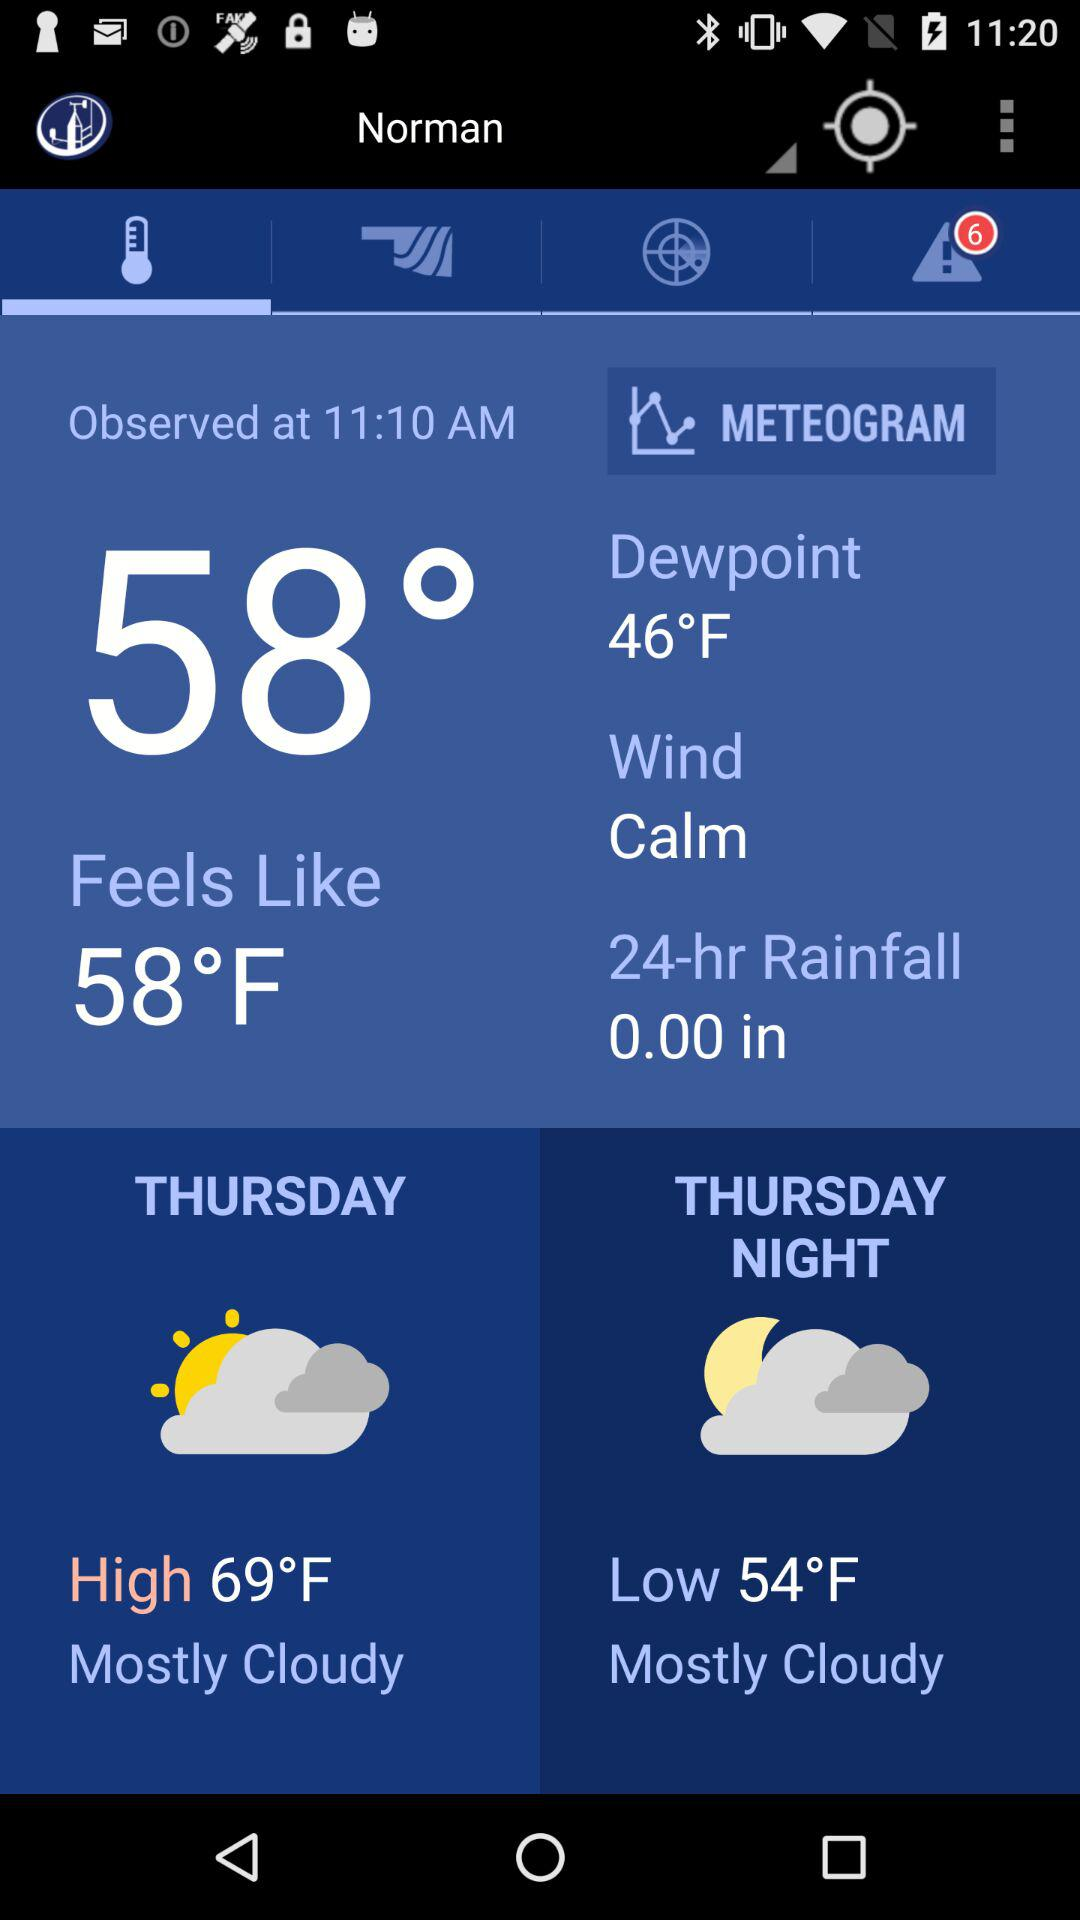Which tab has been selected? The selected tab is "Temperature". 